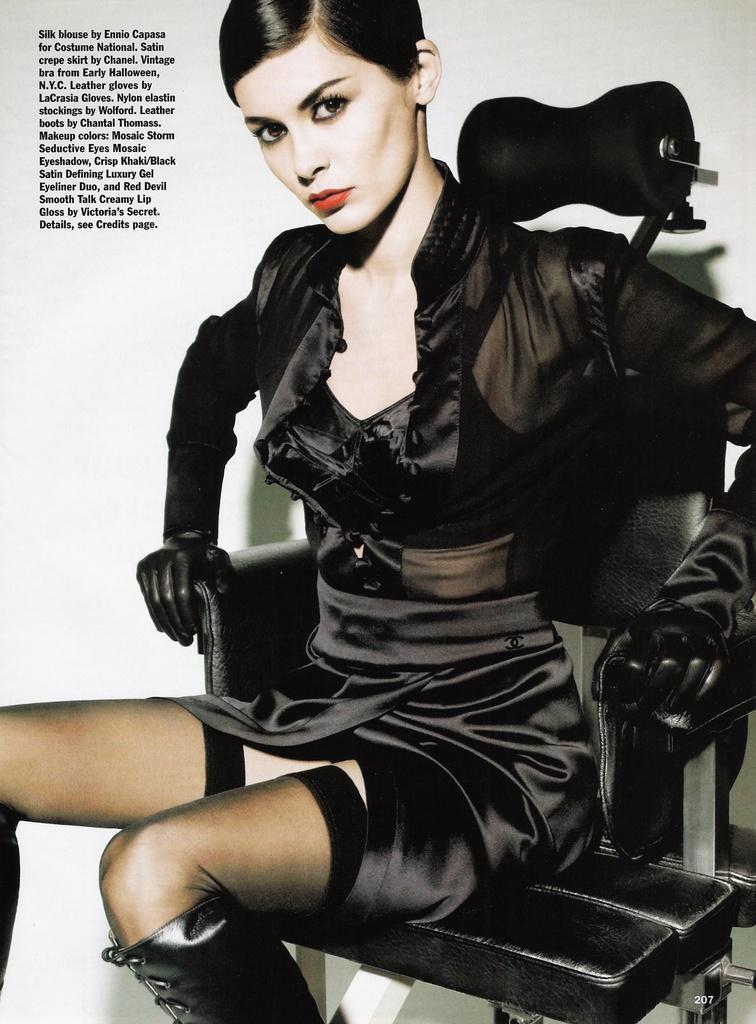Could you give a brief overview of what you see in this image? This person sitting on the chair and wear black color dress. 